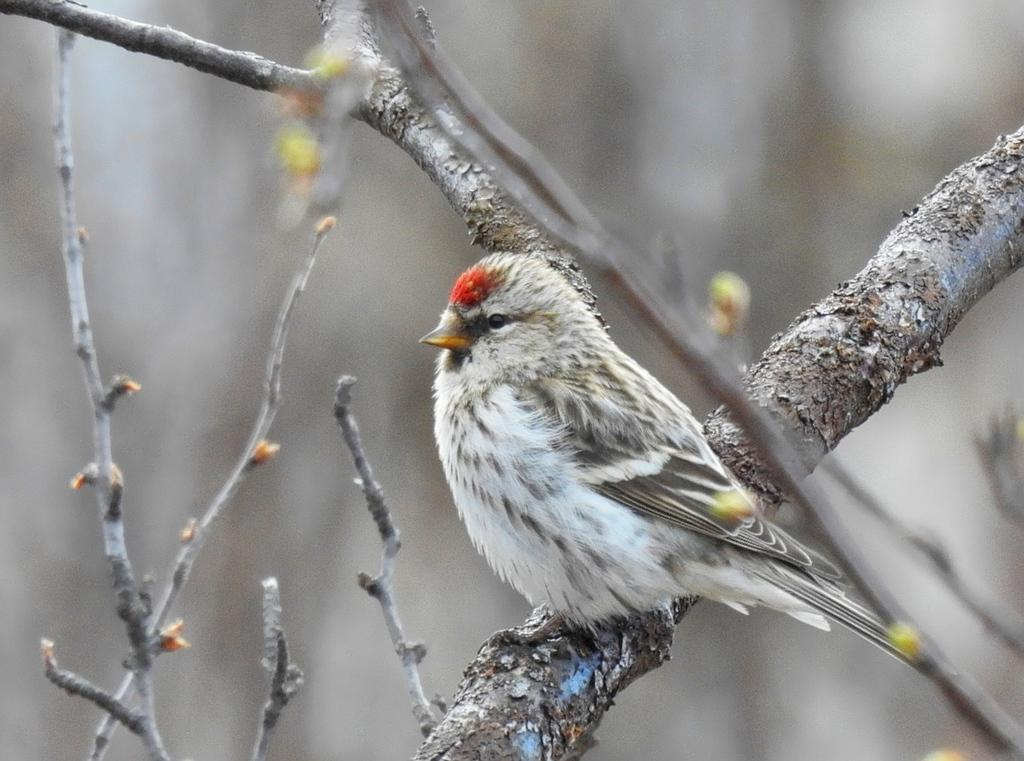What type of animal can be seen in the image? There is a bird in the image. Where is the bird located in the image? The bird is on a branch. What else can be seen in the image besides the bird? There are branches visible in the image. How would you describe the background of the image? The background of the image is blurred. How many clocks are hanging on the branches in the image? There are no clocks visible in the image; it features a bird on a branch with other branches in the background. What type of pail is being used by the bird in the image? There is no pail present in the image; it features a bird on a branch with other branches in the background. 